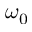Convert formula to latex. <formula><loc_0><loc_0><loc_500><loc_500>\omega _ { 0 }</formula> 